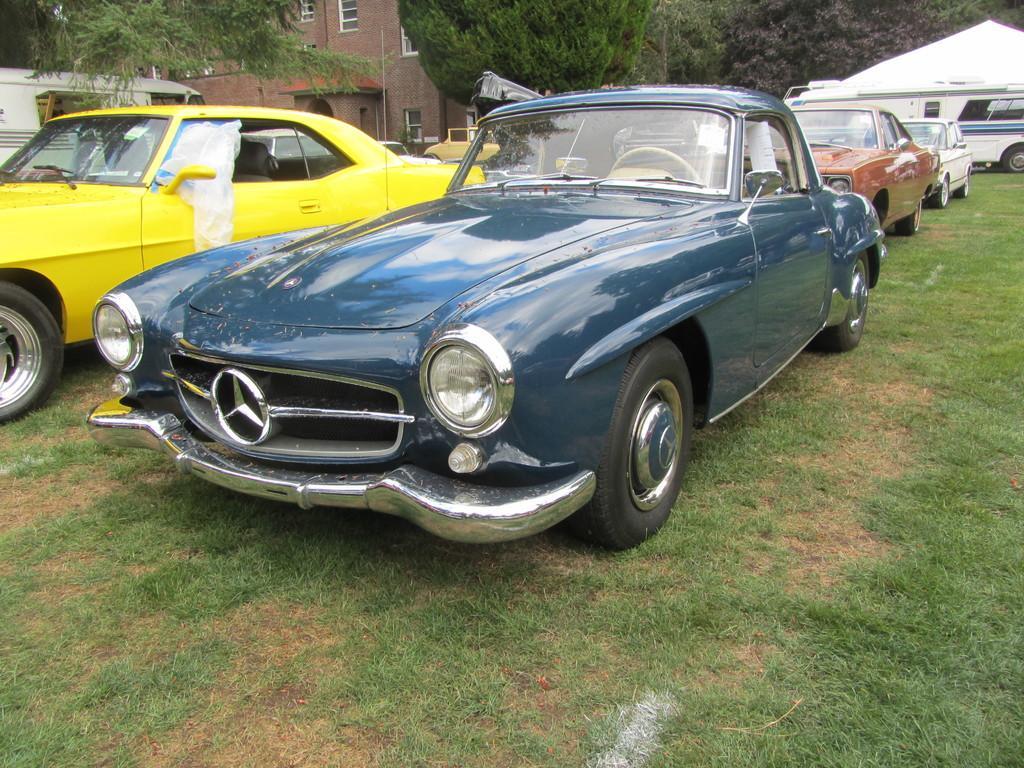Could you give a brief overview of what you see in this image? In this image we can see vehicles. In the background there is a building, trees and a tent. At the bottom there is grass. 